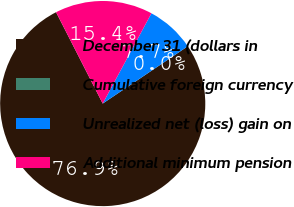<chart> <loc_0><loc_0><loc_500><loc_500><pie_chart><fcel>December 31 (dollars in<fcel>Cumulative foreign currency<fcel>Unrealized net (loss) gain on<fcel>Additional minimum pension<nl><fcel>76.92%<fcel>0.0%<fcel>7.69%<fcel>15.39%<nl></chart> 